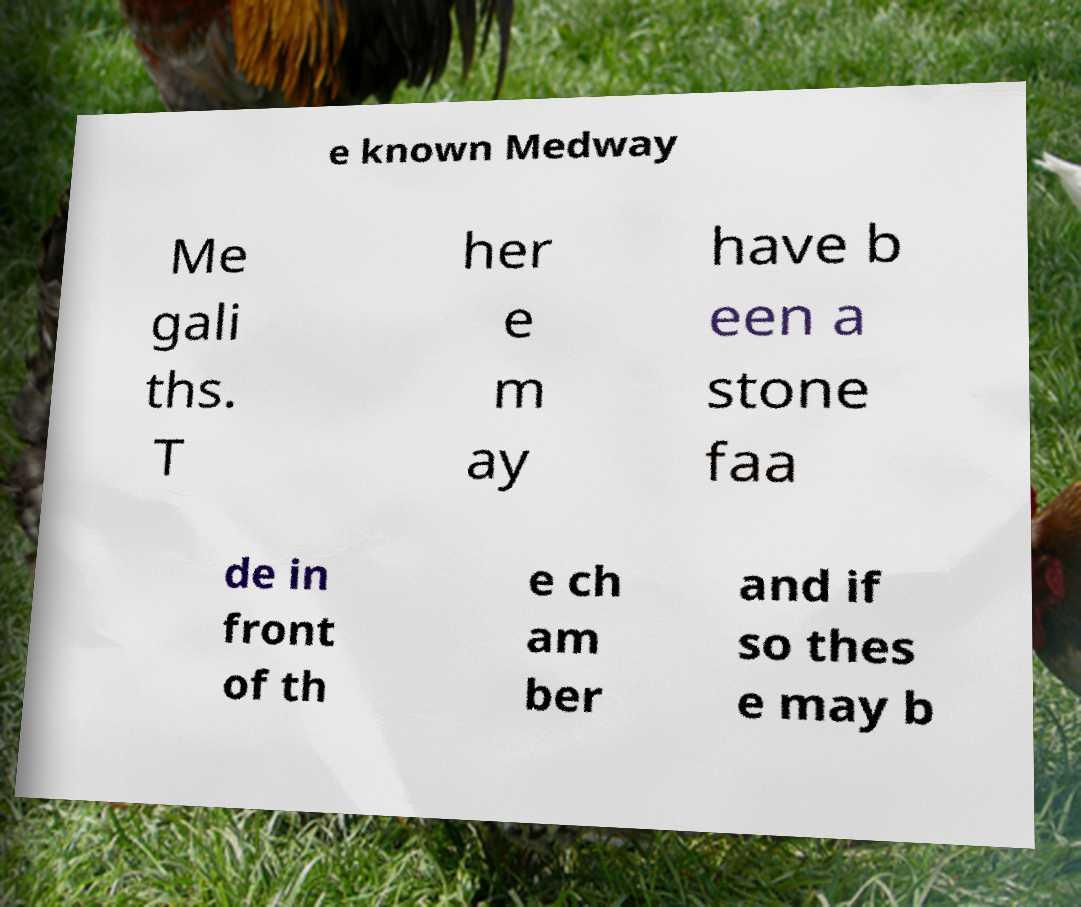Could you assist in decoding the text presented in this image and type it out clearly? e known Medway Me gali ths. T her e m ay have b een a stone faa de in front of th e ch am ber and if so thes e may b 